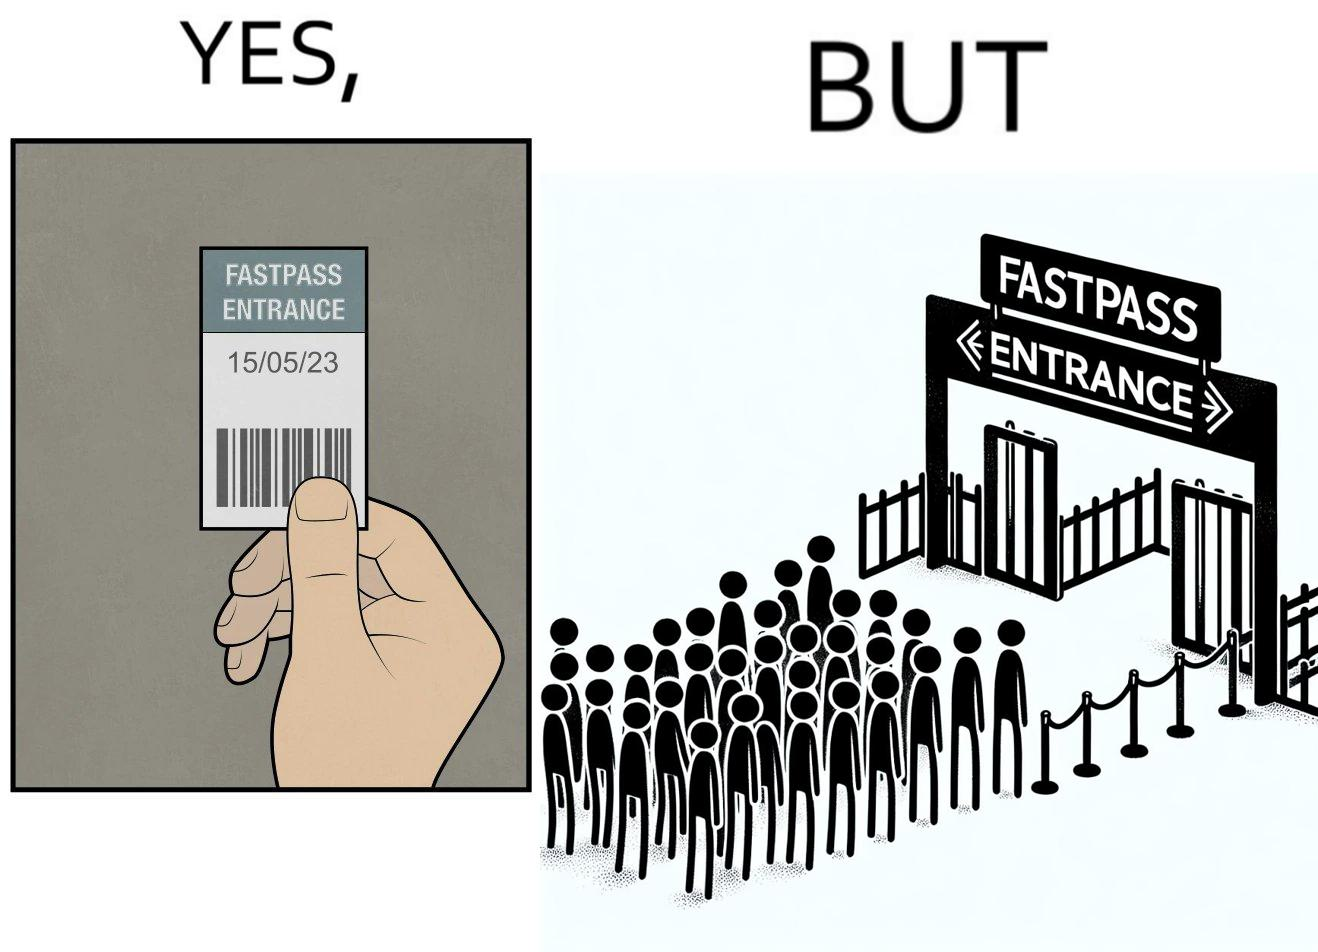Why is this image considered satirical? The image is ironic, because fast pass entrance was meant for people to pass the gate fast but as more no. of people bought the pass due to which the queue has become longer and it becomes slow and time consuming 